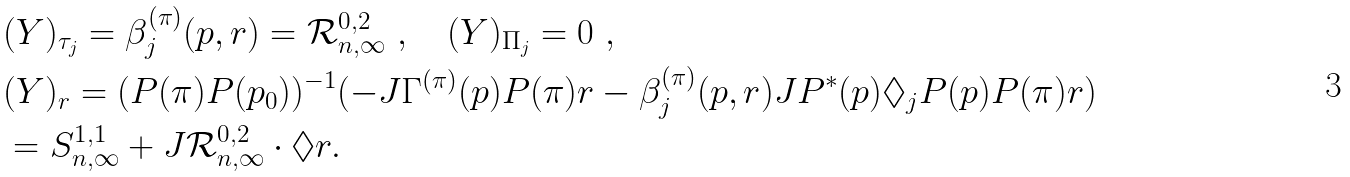Convert formula to latex. <formula><loc_0><loc_0><loc_500><loc_500>& ( Y ) _ { \tau _ { j } } = \beta _ { j } ^ { ( \pi ) } ( p , r ) = \mathcal { R } ^ { 0 , 2 } _ { n , \infty } \ , \quad ( Y ) _ { \Pi _ { j } } = 0 \ , \\ & ( Y ) _ { r } = ( P ( \pi ) P ( p _ { 0 } ) ) ^ { - 1 } ( - J \Gamma ^ { ( \pi ) } ( p ) P ( \pi ) r - \beta _ { j } ^ { ( \pi ) } ( p , r ) J P ^ { * } ( p ) \Diamond _ { j } P ( p ) P ( \pi ) r ) \\ & = S ^ { 1 , 1 } _ { n , \infty } + J \mathcal { R } ^ { 0 , 2 } _ { n , \infty } \cdot \Diamond r .</formula> 